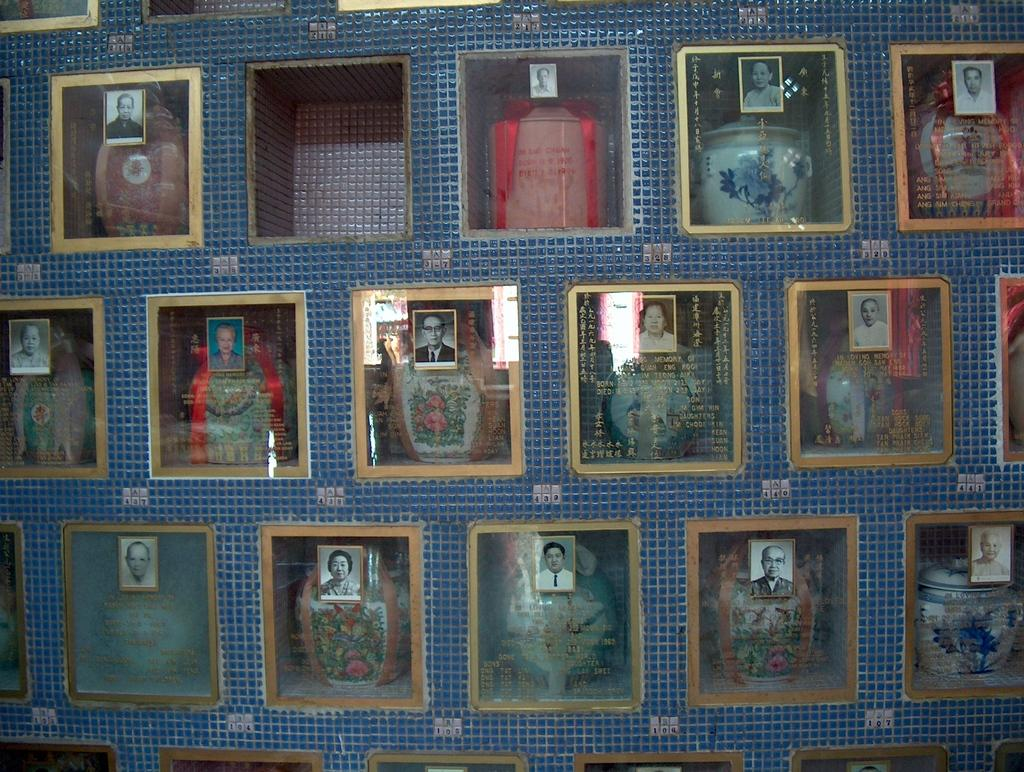What objects are present in the image? There is a collection of vases in the image. Where are the vases located? The vases are placed on a shelf. What is unique about the vases in the image? There are photographs pasted on the glasses of the vases. What type of produce can be seen growing in the image? There is no produce visible in the image; it features a collection of vases with photographs pasted on their glasses. What kind of apparatus is used to clean the vases in the image? There is no apparatus shown for cleaning the vases in the image. 